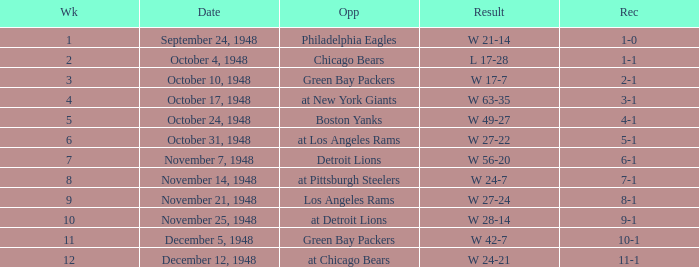What was the record for December 5, 1948? 10-1. 